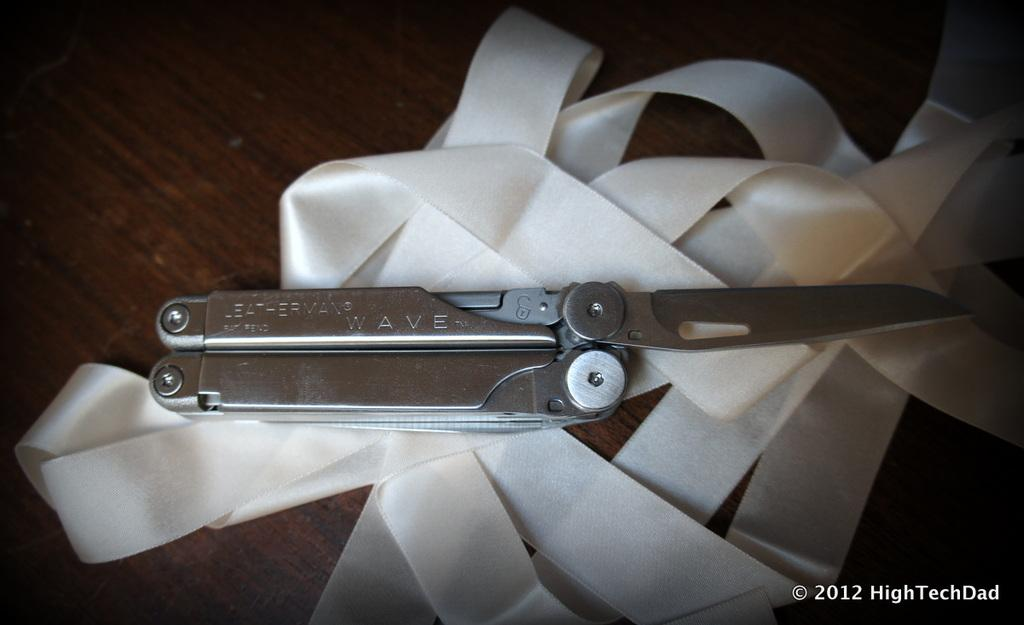What object is located on the table in the image? There is a knife on the table in the image. What other item can be seen on the table in the image? There is a ribbon on the table in the image. Is there any text present in the image? Yes, there is some text at the bottom of the image. What type of wire is being used to hold the knife in the image? There is no wire present in the image; the knife is simply resting on the table. 